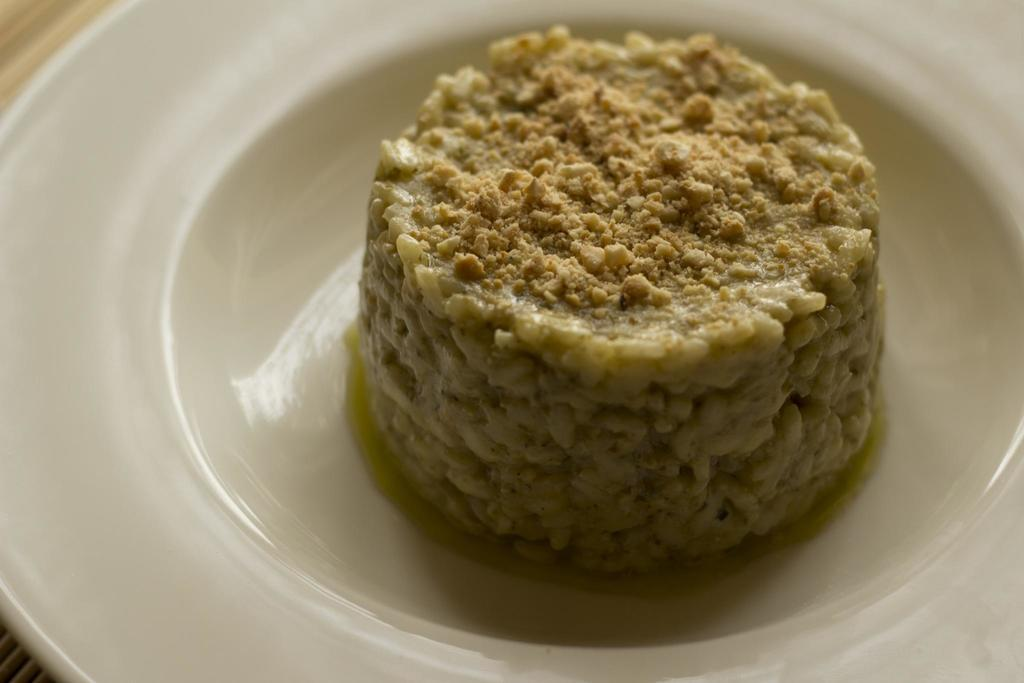What is the main subject of the image? There is a food item on a platter in the image. Can you describe the food item in more detail? Unfortunately, the specific food item cannot be identified from the given facts. Is there any context or setting provided for the image? No, there is no additional context or setting provided beyond the food item on a platter. Who is the owner of the jail depicted in the image? There is no jail present in the image; it only features a food item on a platter. What type of stem can be seen growing from the food item in the image? There is no stem present in the image, as it only features a food item on a platter. 